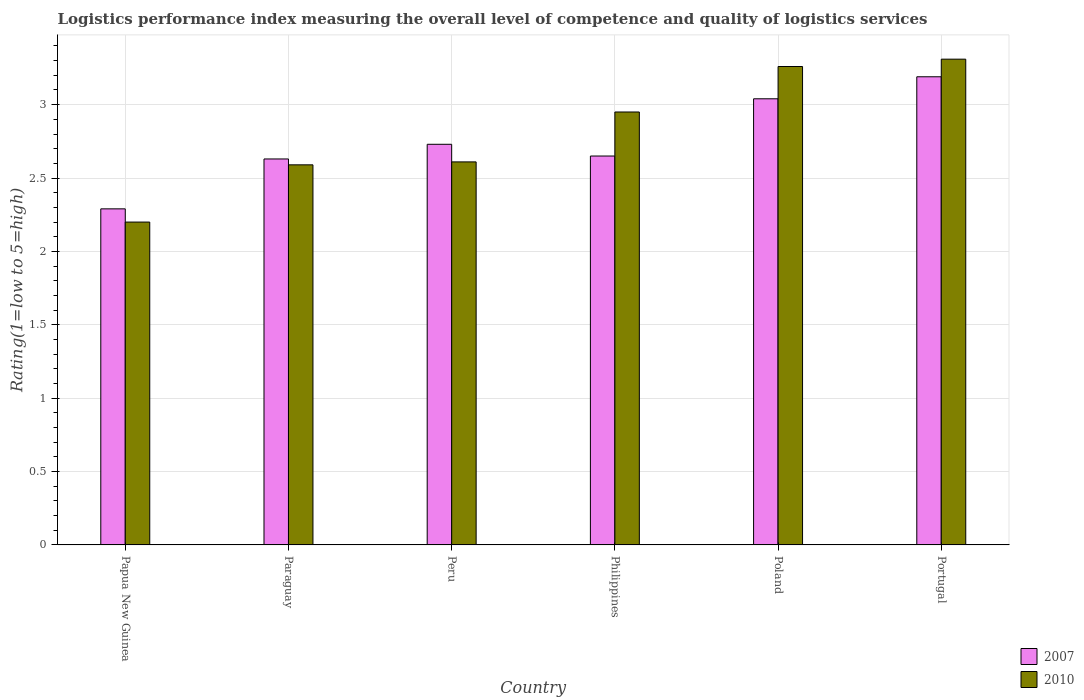How many different coloured bars are there?
Your answer should be compact. 2. How many groups of bars are there?
Your answer should be very brief. 6. Are the number of bars per tick equal to the number of legend labels?
Offer a very short reply. Yes. Are the number of bars on each tick of the X-axis equal?
Your response must be concise. Yes. How many bars are there on the 3rd tick from the left?
Provide a short and direct response. 2. How many bars are there on the 1st tick from the right?
Offer a very short reply. 2. What is the Logistic performance index in 2007 in Papua New Guinea?
Keep it short and to the point. 2.29. Across all countries, what is the maximum Logistic performance index in 2007?
Your answer should be compact. 3.19. In which country was the Logistic performance index in 2010 minimum?
Provide a succinct answer. Papua New Guinea. What is the total Logistic performance index in 2007 in the graph?
Make the answer very short. 16.53. What is the difference between the Logistic performance index in 2007 in Paraguay and that in Poland?
Ensure brevity in your answer.  -0.41. What is the difference between the Logistic performance index in 2007 in Portugal and the Logistic performance index in 2010 in Philippines?
Provide a succinct answer. 0.24. What is the average Logistic performance index in 2007 per country?
Your answer should be very brief. 2.76. What is the difference between the Logistic performance index of/in 2007 and Logistic performance index of/in 2010 in Peru?
Your answer should be compact. 0.12. In how many countries, is the Logistic performance index in 2010 greater than 2.5?
Provide a short and direct response. 5. What is the ratio of the Logistic performance index in 2007 in Peru to that in Portugal?
Offer a very short reply. 0.86. Is the difference between the Logistic performance index in 2007 in Philippines and Portugal greater than the difference between the Logistic performance index in 2010 in Philippines and Portugal?
Your response must be concise. No. What is the difference between the highest and the second highest Logistic performance index in 2010?
Provide a succinct answer. 0.31. What is the difference between the highest and the lowest Logistic performance index in 2010?
Provide a short and direct response. 1.11. In how many countries, is the Logistic performance index in 2007 greater than the average Logistic performance index in 2007 taken over all countries?
Offer a very short reply. 2. Is the sum of the Logistic performance index in 2007 in Peru and Poland greater than the maximum Logistic performance index in 2010 across all countries?
Give a very brief answer. Yes. What does the 1st bar from the left in Poland represents?
Your response must be concise. 2007. How many bars are there?
Offer a very short reply. 12. How many countries are there in the graph?
Your answer should be compact. 6. Does the graph contain any zero values?
Ensure brevity in your answer.  No. Where does the legend appear in the graph?
Your response must be concise. Bottom right. How many legend labels are there?
Ensure brevity in your answer.  2. How are the legend labels stacked?
Your answer should be compact. Vertical. What is the title of the graph?
Your response must be concise. Logistics performance index measuring the overall level of competence and quality of logistics services. What is the label or title of the Y-axis?
Offer a terse response. Rating(1=low to 5=high). What is the Rating(1=low to 5=high) of 2007 in Papua New Guinea?
Offer a terse response. 2.29. What is the Rating(1=low to 5=high) of 2007 in Paraguay?
Your response must be concise. 2.63. What is the Rating(1=low to 5=high) in 2010 in Paraguay?
Keep it short and to the point. 2.59. What is the Rating(1=low to 5=high) of 2007 in Peru?
Offer a terse response. 2.73. What is the Rating(1=low to 5=high) of 2010 in Peru?
Make the answer very short. 2.61. What is the Rating(1=low to 5=high) in 2007 in Philippines?
Offer a terse response. 2.65. What is the Rating(1=low to 5=high) in 2010 in Philippines?
Give a very brief answer. 2.95. What is the Rating(1=low to 5=high) of 2007 in Poland?
Make the answer very short. 3.04. What is the Rating(1=low to 5=high) of 2010 in Poland?
Your answer should be very brief. 3.26. What is the Rating(1=low to 5=high) of 2007 in Portugal?
Your answer should be very brief. 3.19. What is the Rating(1=low to 5=high) in 2010 in Portugal?
Make the answer very short. 3.31. Across all countries, what is the maximum Rating(1=low to 5=high) in 2007?
Offer a very short reply. 3.19. Across all countries, what is the maximum Rating(1=low to 5=high) in 2010?
Give a very brief answer. 3.31. Across all countries, what is the minimum Rating(1=low to 5=high) of 2007?
Provide a succinct answer. 2.29. What is the total Rating(1=low to 5=high) in 2007 in the graph?
Keep it short and to the point. 16.53. What is the total Rating(1=low to 5=high) of 2010 in the graph?
Ensure brevity in your answer.  16.92. What is the difference between the Rating(1=low to 5=high) of 2007 in Papua New Guinea and that in Paraguay?
Offer a terse response. -0.34. What is the difference between the Rating(1=low to 5=high) in 2010 in Papua New Guinea and that in Paraguay?
Your answer should be very brief. -0.39. What is the difference between the Rating(1=low to 5=high) of 2007 in Papua New Guinea and that in Peru?
Provide a short and direct response. -0.44. What is the difference between the Rating(1=low to 5=high) of 2010 in Papua New Guinea and that in Peru?
Provide a short and direct response. -0.41. What is the difference between the Rating(1=low to 5=high) in 2007 in Papua New Guinea and that in Philippines?
Your answer should be very brief. -0.36. What is the difference between the Rating(1=low to 5=high) of 2010 in Papua New Guinea and that in Philippines?
Provide a short and direct response. -0.75. What is the difference between the Rating(1=low to 5=high) of 2007 in Papua New Guinea and that in Poland?
Give a very brief answer. -0.75. What is the difference between the Rating(1=low to 5=high) in 2010 in Papua New Guinea and that in Poland?
Provide a short and direct response. -1.06. What is the difference between the Rating(1=low to 5=high) of 2010 in Papua New Guinea and that in Portugal?
Provide a short and direct response. -1.11. What is the difference between the Rating(1=low to 5=high) of 2010 in Paraguay and that in Peru?
Keep it short and to the point. -0.02. What is the difference between the Rating(1=low to 5=high) in 2007 in Paraguay and that in Philippines?
Provide a succinct answer. -0.02. What is the difference between the Rating(1=low to 5=high) in 2010 in Paraguay and that in Philippines?
Ensure brevity in your answer.  -0.36. What is the difference between the Rating(1=low to 5=high) of 2007 in Paraguay and that in Poland?
Keep it short and to the point. -0.41. What is the difference between the Rating(1=low to 5=high) in 2010 in Paraguay and that in Poland?
Ensure brevity in your answer.  -0.67. What is the difference between the Rating(1=low to 5=high) in 2007 in Paraguay and that in Portugal?
Provide a short and direct response. -0.56. What is the difference between the Rating(1=low to 5=high) of 2010 in Paraguay and that in Portugal?
Make the answer very short. -0.72. What is the difference between the Rating(1=low to 5=high) in 2007 in Peru and that in Philippines?
Your response must be concise. 0.08. What is the difference between the Rating(1=low to 5=high) of 2010 in Peru and that in Philippines?
Give a very brief answer. -0.34. What is the difference between the Rating(1=low to 5=high) in 2007 in Peru and that in Poland?
Make the answer very short. -0.31. What is the difference between the Rating(1=low to 5=high) of 2010 in Peru and that in Poland?
Provide a succinct answer. -0.65. What is the difference between the Rating(1=low to 5=high) in 2007 in Peru and that in Portugal?
Offer a terse response. -0.46. What is the difference between the Rating(1=low to 5=high) of 2007 in Philippines and that in Poland?
Give a very brief answer. -0.39. What is the difference between the Rating(1=low to 5=high) of 2010 in Philippines and that in Poland?
Your response must be concise. -0.31. What is the difference between the Rating(1=low to 5=high) in 2007 in Philippines and that in Portugal?
Ensure brevity in your answer.  -0.54. What is the difference between the Rating(1=low to 5=high) in 2010 in Philippines and that in Portugal?
Offer a very short reply. -0.36. What is the difference between the Rating(1=low to 5=high) of 2010 in Poland and that in Portugal?
Provide a succinct answer. -0.05. What is the difference between the Rating(1=low to 5=high) in 2007 in Papua New Guinea and the Rating(1=low to 5=high) in 2010 in Peru?
Your answer should be very brief. -0.32. What is the difference between the Rating(1=low to 5=high) in 2007 in Papua New Guinea and the Rating(1=low to 5=high) in 2010 in Philippines?
Ensure brevity in your answer.  -0.66. What is the difference between the Rating(1=low to 5=high) in 2007 in Papua New Guinea and the Rating(1=low to 5=high) in 2010 in Poland?
Offer a terse response. -0.97. What is the difference between the Rating(1=low to 5=high) of 2007 in Papua New Guinea and the Rating(1=low to 5=high) of 2010 in Portugal?
Your response must be concise. -1.02. What is the difference between the Rating(1=low to 5=high) in 2007 in Paraguay and the Rating(1=low to 5=high) in 2010 in Philippines?
Your response must be concise. -0.32. What is the difference between the Rating(1=low to 5=high) of 2007 in Paraguay and the Rating(1=low to 5=high) of 2010 in Poland?
Your response must be concise. -0.63. What is the difference between the Rating(1=low to 5=high) in 2007 in Paraguay and the Rating(1=low to 5=high) in 2010 in Portugal?
Make the answer very short. -0.68. What is the difference between the Rating(1=low to 5=high) of 2007 in Peru and the Rating(1=low to 5=high) of 2010 in Philippines?
Offer a terse response. -0.22. What is the difference between the Rating(1=low to 5=high) in 2007 in Peru and the Rating(1=low to 5=high) in 2010 in Poland?
Offer a very short reply. -0.53. What is the difference between the Rating(1=low to 5=high) of 2007 in Peru and the Rating(1=low to 5=high) of 2010 in Portugal?
Give a very brief answer. -0.58. What is the difference between the Rating(1=low to 5=high) in 2007 in Philippines and the Rating(1=low to 5=high) in 2010 in Poland?
Ensure brevity in your answer.  -0.61. What is the difference between the Rating(1=low to 5=high) in 2007 in Philippines and the Rating(1=low to 5=high) in 2010 in Portugal?
Your response must be concise. -0.66. What is the difference between the Rating(1=low to 5=high) of 2007 in Poland and the Rating(1=low to 5=high) of 2010 in Portugal?
Your answer should be very brief. -0.27. What is the average Rating(1=low to 5=high) in 2007 per country?
Keep it short and to the point. 2.75. What is the average Rating(1=low to 5=high) of 2010 per country?
Ensure brevity in your answer.  2.82. What is the difference between the Rating(1=low to 5=high) of 2007 and Rating(1=low to 5=high) of 2010 in Papua New Guinea?
Provide a succinct answer. 0.09. What is the difference between the Rating(1=low to 5=high) in 2007 and Rating(1=low to 5=high) in 2010 in Paraguay?
Provide a short and direct response. 0.04. What is the difference between the Rating(1=low to 5=high) of 2007 and Rating(1=low to 5=high) of 2010 in Peru?
Provide a short and direct response. 0.12. What is the difference between the Rating(1=low to 5=high) in 2007 and Rating(1=low to 5=high) in 2010 in Philippines?
Offer a very short reply. -0.3. What is the difference between the Rating(1=low to 5=high) in 2007 and Rating(1=low to 5=high) in 2010 in Poland?
Make the answer very short. -0.22. What is the difference between the Rating(1=low to 5=high) of 2007 and Rating(1=low to 5=high) of 2010 in Portugal?
Your answer should be compact. -0.12. What is the ratio of the Rating(1=low to 5=high) in 2007 in Papua New Guinea to that in Paraguay?
Give a very brief answer. 0.87. What is the ratio of the Rating(1=low to 5=high) in 2010 in Papua New Guinea to that in Paraguay?
Provide a succinct answer. 0.85. What is the ratio of the Rating(1=low to 5=high) of 2007 in Papua New Guinea to that in Peru?
Offer a very short reply. 0.84. What is the ratio of the Rating(1=low to 5=high) in 2010 in Papua New Guinea to that in Peru?
Your answer should be compact. 0.84. What is the ratio of the Rating(1=low to 5=high) of 2007 in Papua New Guinea to that in Philippines?
Give a very brief answer. 0.86. What is the ratio of the Rating(1=low to 5=high) of 2010 in Papua New Guinea to that in Philippines?
Offer a terse response. 0.75. What is the ratio of the Rating(1=low to 5=high) of 2007 in Papua New Guinea to that in Poland?
Keep it short and to the point. 0.75. What is the ratio of the Rating(1=low to 5=high) of 2010 in Papua New Guinea to that in Poland?
Your response must be concise. 0.67. What is the ratio of the Rating(1=low to 5=high) in 2007 in Papua New Guinea to that in Portugal?
Give a very brief answer. 0.72. What is the ratio of the Rating(1=low to 5=high) in 2010 in Papua New Guinea to that in Portugal?
Your answer should be compact. 0.66. What is the ratio of the Rating(1=low to 5=high) of 2007 in Paraguay to that in Peru?
Offer a very short reply. 0.96. What is the ratio of the Rating(1=low to 5=high) in 2010 in Paraguay to that in Philippines?
Provide a succinct answer. 0.88. What is the ratio of the Rating(1=low to 5=high) in 2007 in Paraguay to that in Poland?
Offer a very short reply. 0.87. What is the ratio of the Rating(1=low to 5=high) of 2010 in Paraguay to that in Poland?
Provide a succinct answer. 0.79. What is the ratio of the Rating(1=low to 5=high) in 2007 in Paraguay to that in Portugal?
Your answer should be compact. 0.82. What is the ratio of the Rating(1=low to 5=high) in 2010 in Paraguay to that in Portugal?
Offer a very short reply. 0.78. What is the ratio of the Rating(1=low to 5=high) in 2007 in Peru to that in Philippines?
Provide a succinct answer. 1.03. What is the ratio of the Rating(1=low to 5=high) in 2010 in Peru to that in Philippines?
Offer a terse response. 0.88. What is the ratio of the Rating(1=low to 5=high) of 2007 in Peru to that in Poland?
Ensure brevity in your answer.  0.9. What is the ratio of the Rating(1=low to 5=high) of 2010 in Peru to that in Poland?
Provide a succinct answer. 0.8. What is the ratio of the Rating(1=low to 5=high) of 2007 in Peru to that in Portugal?
Your answer should be compact. 0.86. What is the ratio of the Rating(1=low to 5=high) in 2010 in Peru to that in Portugal?
Give a very brief answer. 0.79. What is the ratio of the Rating(1=low to 5=high) of 2007 in Philippines to that in Poland?
Make the answer very short. 0.87. What is the ratio of the Rating(1=low to 5=high) in 2010 in Philippines to that in Poland?
Provide a short and direct response. 0.9. What is the ratio of the Rating(1=low to 5=high) of 2007 in Philippines to that in Portugal?
Give a very brief answer. 0.83. What is the ratio of the Rating(1=low to 5=high) in 2010 in Philippines to that in Portugal?
Your answer should be compact. 0.89. What is the ratio of the Rating(1=low to 5=high) of 2007 in Poland to that in Portugal?
Offer a very short reply. 0.95. What is the ratio of the Rating(1=low to 5=high) in 2010 in Poland to that in Portugal?
Keep it short and to the point. 0.98. What is the difference between the highest and the second highest Rating(1=low to 5=high) of 2010?
Your answer should be very brief. 0.05. What is the difference between the highest and the lowest Rating(1=low to 5=high) of 2007?
Give a very brief answer. 0.9. What is the difference between the highest and the lowest Rating(1=low to 5=high) of 2010?
Make the answer very short. 1.11. 